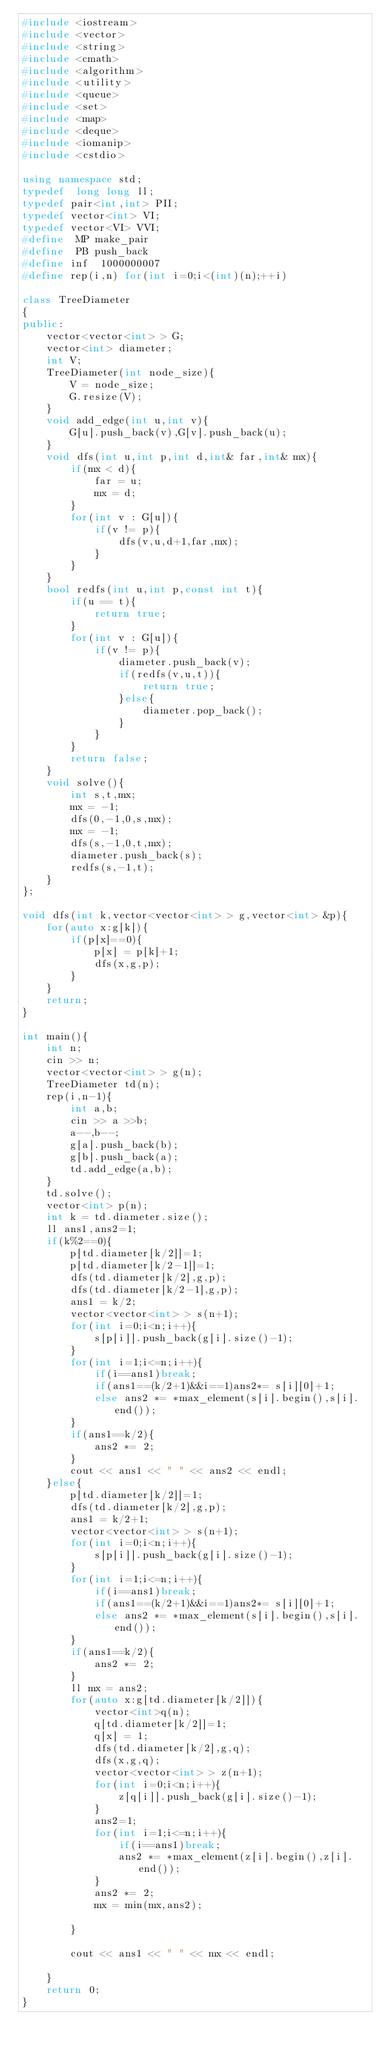<code> <loc_0><loc_0><loc_500><loc_500><_C++_>#include <iostream>
#include <vector>
#include <string>
#include <cmath>
#include <algorithm>
#include <utility>
#include <queue>
#include <set>
#include <map>
#include <deque>
#include <iomanip>
#include <cstdio>

using namespace std;
typedef  long long ll;
typedef pair<int,int> PII;
typedef vector<int> VI;
typedef vector<VI> VVI;
#define  MP make_pair
#define  PB push_back
#define inf  1000000007
#define rep(i,n) for(int i=0;i<(int)(n);++i)

class TreeDiameter
{
public:
    vector<vector<int> > G;
    vector<int> diameter;
    int V;
    TreeDiameter(int node_size){
        V = node_size;
        G.resize(V);
    }
    void add_edge(int u,int v){
        G[u].push_back(v),G[v].push_back(u);
    }
    void dfs(int u,int p,int d,int& far,int& mx){
        if(mx < d){
            far = u;
            mx = d;
        }
        for(int v : G[u]){
            if(v != p){
                dfs(v,u,d+1,far,mx);
            }
        }
    }
    bool redfs(int u,int p,const int t){
        if(u == t){
            return true;
        }
        for(int v : G[u]){
            if(v != p){
                diameter.push_back(v);
                if(redfs(v,u,t)){
                    return true;
                }else{
                    diameter.pop_back();
                }
            }
        }
        return false;
    }
    void solve(){
        int s,t,mx;
        mx = -1;
        dfs(0,-1,0,s,mx);
        mx = -1;
        dfs(s,-1,0,t,mx);
        diameter.push_back(s);
        redfs(s,-1,t);
    }
};

void dfs(int k,vector<vector<int> > g,vector<int> &p){
    for(auto x:g[k]){
        if(p[x]==0){
            p[x] = p[k]+1;
            dfs(x,g,p);
        }
    }
    return;
}

int main(){
    int n;
    cin >> n;
    vector<vector<int> > g(n);
    TreeDiameter td(n);
    rep(i,n-1){
        int a,b;
        cin >> a >>b;
        a--,b--;
        g[a].push_back(b);
        g[b].push_back(a);
        td.add_edge(a,b);
    }
    td.solve();
    vector<int> p(n);
    int k = td.diameter.size();
    ll ans1,ans2=1;
    if(k%2==0){
        p[td.diameter[k/2]]=1;
        p[td.diameter[k/2-1]]=1;
        dfs(td.diameter[k/2],g,p);
        dfs(td.diameter[k/2-1],g,p);
        ans1 = k/2;
        vector<vector<int> > s(n+1);
        for(int i=0;i<n;i++){
            s[p[i]].push_back(g[i].size()-1);
        }
        for(int i=1;i<=n;i++){
            if(i==ans1)break;
            if(ans1==(k/2+1)&&i==1)ans2*= s[i][0]+1; 
            else ans2 *= *max_element(s[i].begin(),s[i].end()); 
        }
        if(ans1==k/2){
            ans2 *= 2;
        }
        cout << ans1 << " " << ans2 << endl;
    }else{
        p[td.diameter[k/2]]=1;
        dfs(td.diameter[k/2],g,p);
        ans1 = k/2+1;
        vector<vector<int> > s(n+1);
        for(int i=0;i<n;i++){
            s[p[i]].push_back(g[i].size()-1);
        }
        for(int i=1;i<=n;i++){
            if(i==ans1)break;
            if(ans1==(k/2+1)&&i==1)ans2*= s[i][0]+1; 
            else ans2 *= *max_element(s[i].begin(),s[i].end()); 
        }
        if(ans1==k/2){
            ans2 *= 2;
        }
        ll mx = ans2;
        for(auto x:g[td.diameter[k/2]]){
            vector<int>q(n);
            q[td.diameter[k/2]]=1;
            q[x] = 1;
            dfs(td.diameter[k/2],g,q);
            dfs(x,g,q);
            vector<vector<int> > z(n+1);
            for(int i=0;i<n;i++){
                z[q[i]].push_back(g[i].size()-1);
            }
            ans2=1;
            for(int i=1;i<=n;i++){
                if(i==ans1)break;
                ans2 *= *max_element(z[i].begin(),z[i].end()); 
            }
            ans2 *= 2;
            mx = min(mx,ans2);

        }

        cout << ans1 << " " << mx << endl;
    
    }
    return 0;
}</code> 